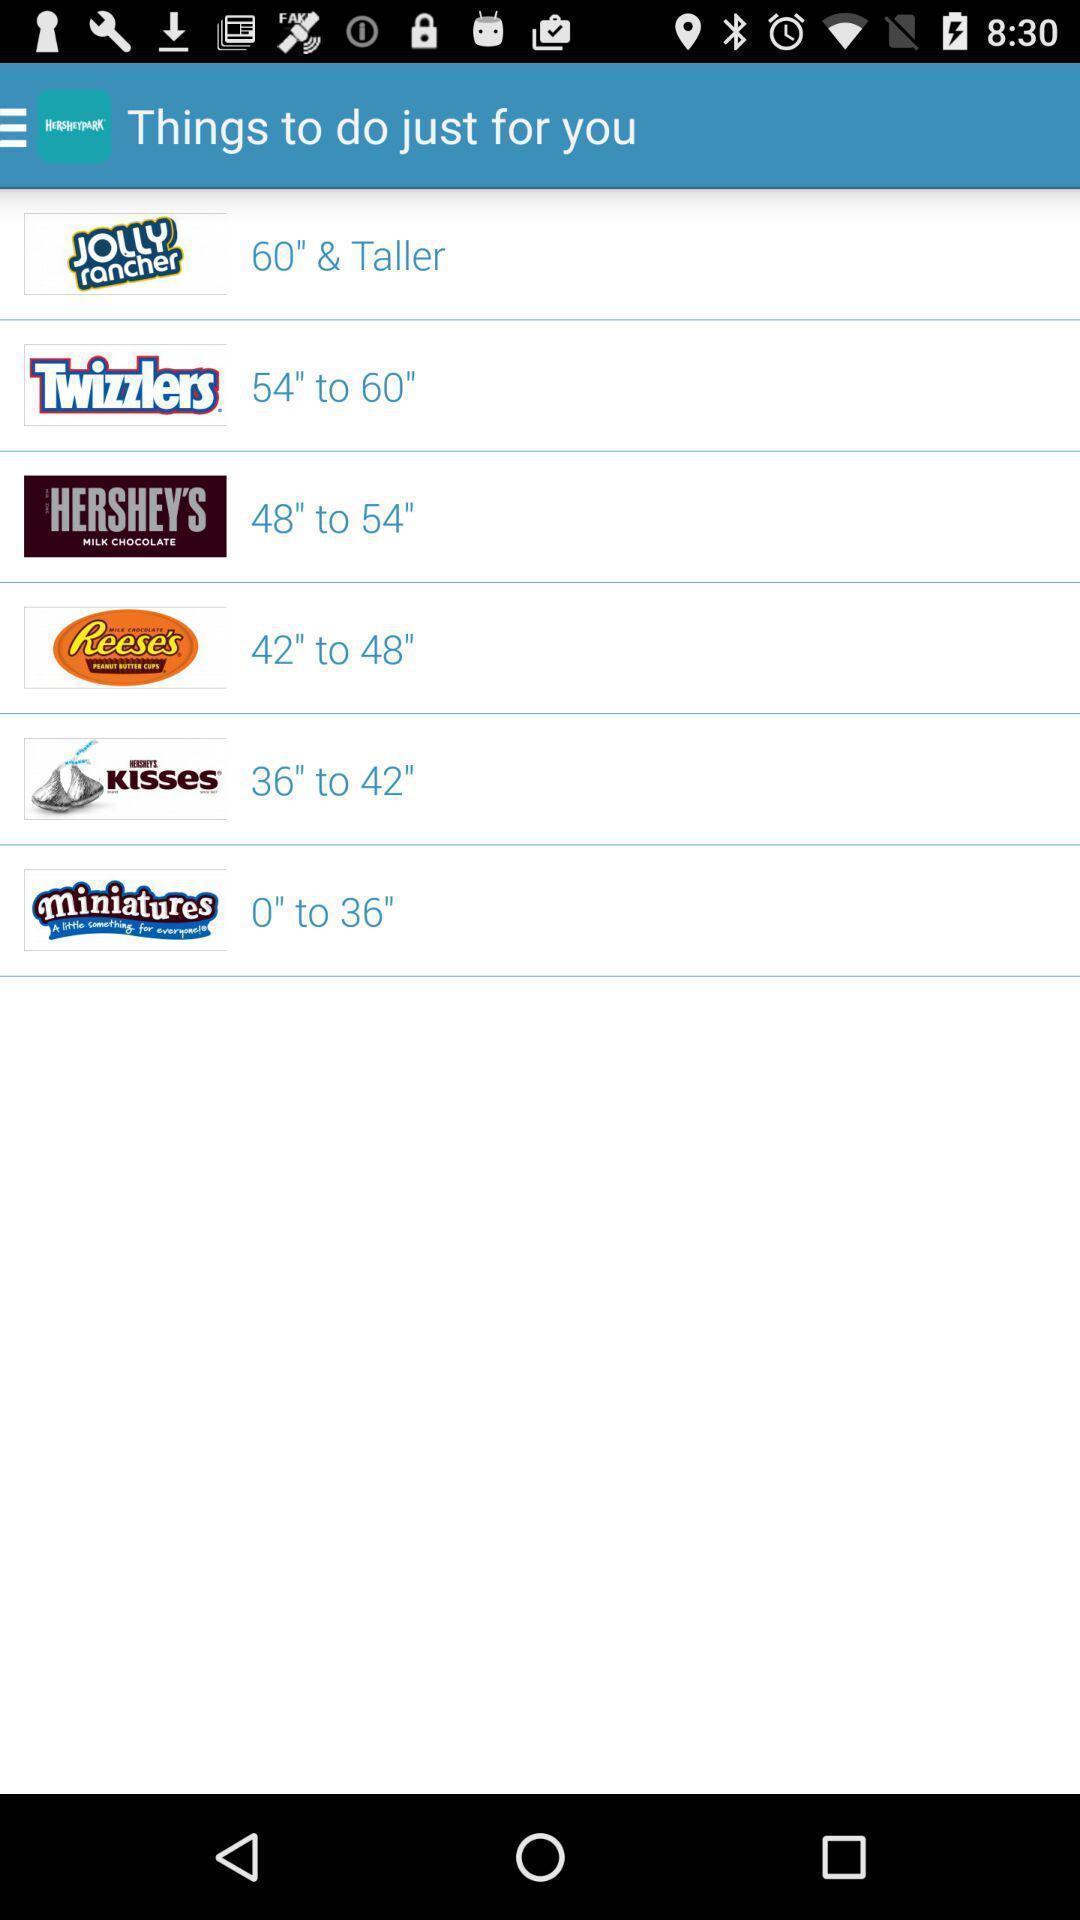Provide a description of this screenshot. Page showing multiple products in app. 